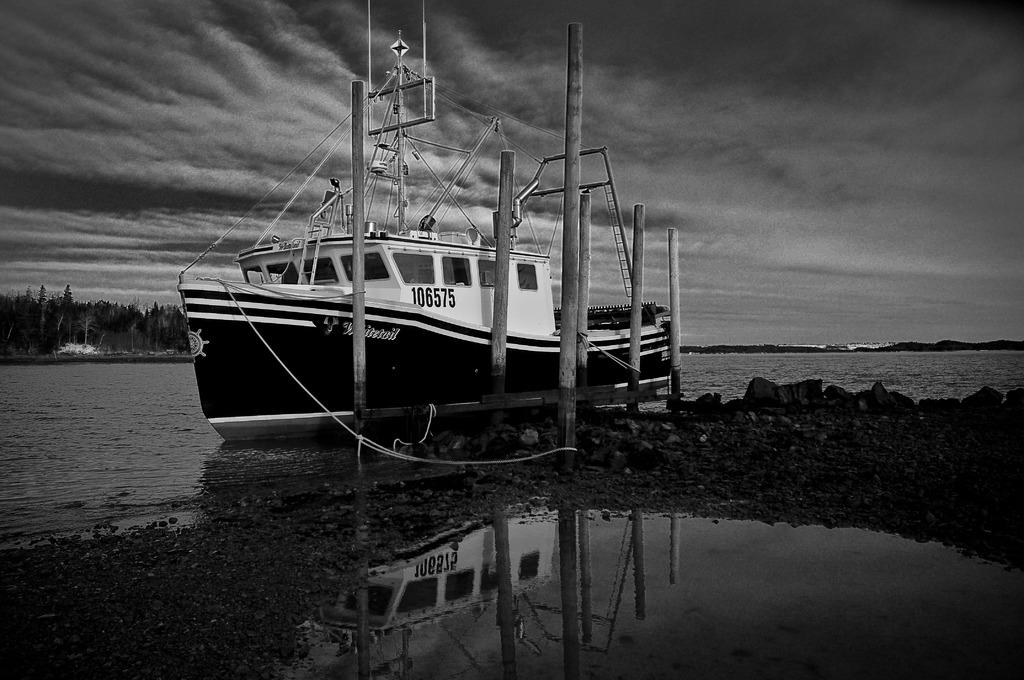What is the main subject of the image? The main subject of the image is a ship above the water. What other objects can be seen in the image? Poles and stones are visible in the image. What can be seen in the background of the image? Trees and the sky are visible in the background of the image. What is the condition of the sky in the image? Clouds are present in the sky. What type of range is being used for the test in the image? There is no range or test present in the image; it features a ship above the water, poles, stones, trees, and a sky with clouds. 